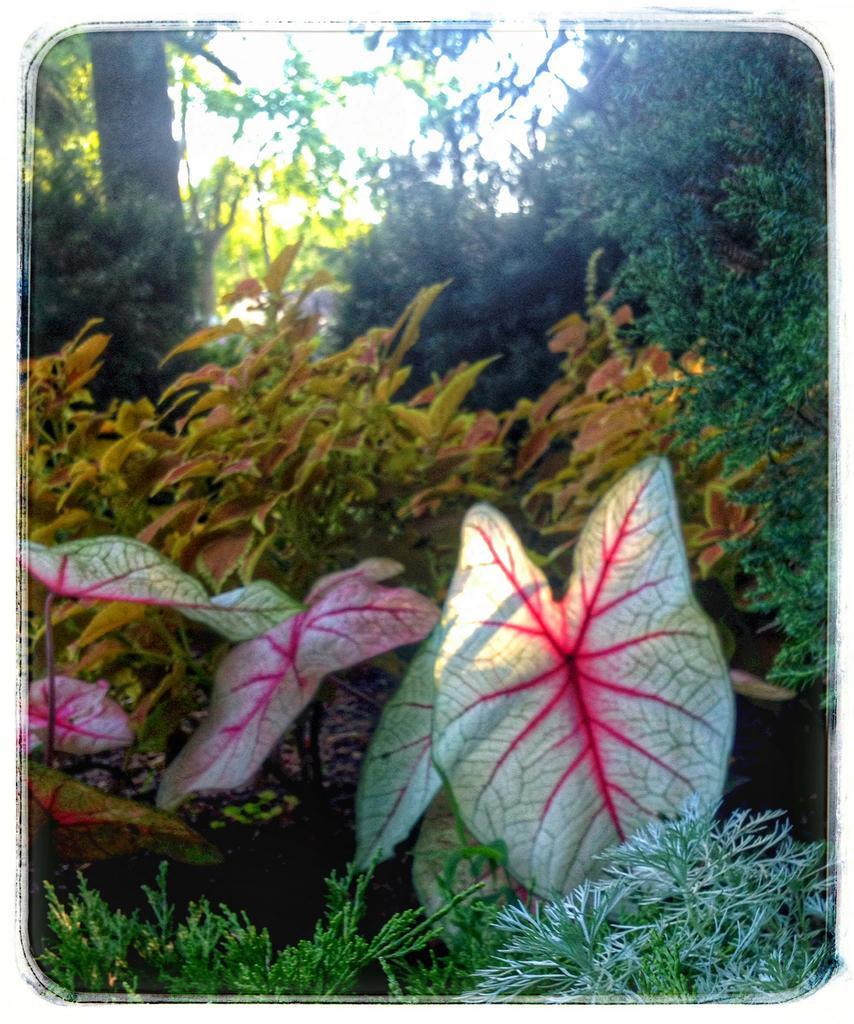Please provide a concise description of this image. In this picture we can see few plants and trees. 